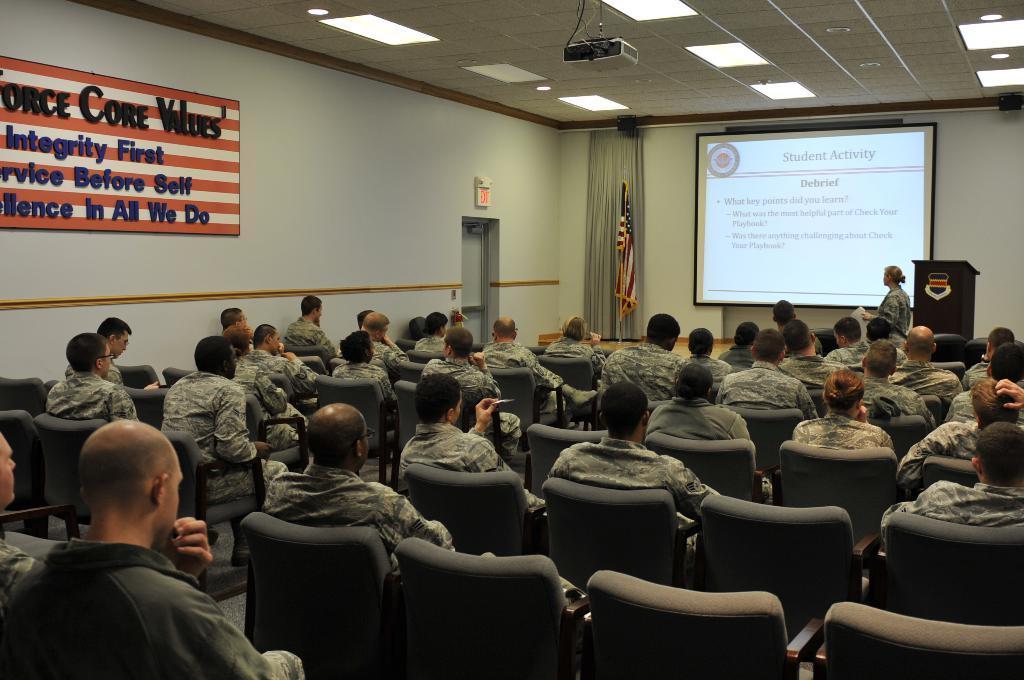Can you describe this image briefly? In this image, group of people are sat on the ash chairs. The right side, we can see podium, woman is standing. At the background, there is a screen, curtain, flag. In the middle ,there is a door. And here board. Left side, we can see a board. The roof ,white color roof, lights , projector we can see. 